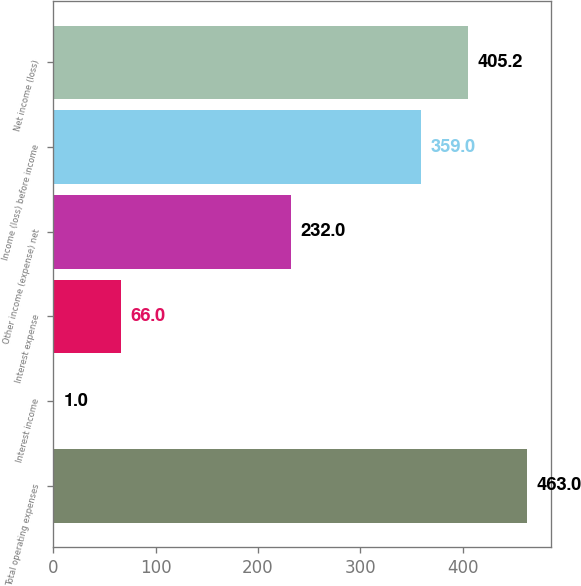Convert chart. <chart><loc_0><loc_0><loc_500><loc_500><bar_chart><fcel>Total operating expenses<fcel>Interest income<fcel>Interest expense<fcel>Other income (expense) net<fcel>Income (loss) before income<fcel>Net income (loss)<nl><fcel>463<fcel>1<fcel>66<fcel>232<fcel>359<fcel>405.2<nl></chart> 